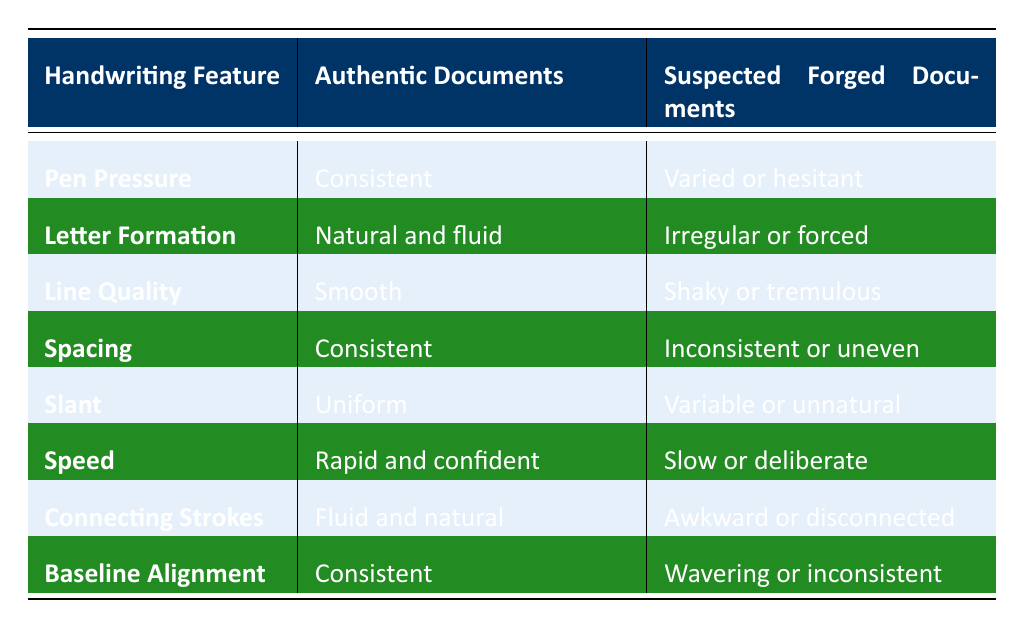What is the description of Pen Pressure in authentic documents? The table states that the Pen Pressure for authentic documents is described as "Consistent". This is directly retrieved from the column under Authentic Documents for the Handwriting Feature of Pen Pressure.
Answer: Consistent How does the Line Quality of suspected forged documents compare to that of authentic documents? The table shows that the Line Quality for authentic documents is "Smooth" while for suspected forged documents it is "Shaky or tremulous". This information is compared directly from the respective rows of the table.
Answer: Shaky or tremulous Is the Spacing of authentic documents described as inconsistent? No, the table indicates that the Spacing for authentic documents is "Consistent". Therefore, the assertion that Spacing is inconsistent is false.
Answer: No What is the difference in Speed between authentic and suspected forged documents? The Speed for authentic documents is "Rapid and confident" while it is "Slow or deliberate" for suspected forged documents. This presents a clear difference from the descriptions given in the table.
Answer: Rapid and confident vs. Slow or deliberate How many handwriting features describe suspected forged documents as having "awkward or disconnected" characteristics? Referring to the table, only the Connecting Strokes feature has the description "Awkward or disconnected" under the Suspected Forged Documents column. It indicates that this unique feature aligns with that specific characteristic upon examination of the data.
Answer: 1 What handwriting features have a description of "Consistent" for authentic documents? From the table, the handwriting features with "Consistent" descriptions for authentic documents are Pen Pressure, Spacing, and Baseline Alignment. These descriptions can be summarized by locating the specified terms in the respective column for authentic documents.
Answer: Pen Pressure, Spacing, Baseline Alignment Are there more handwriting features described as "Natural" in authentic documents than those described as "Irregular" in suspected forged documents? Yes, in the table the features for authentic documents are "Natural and fluid" for Letter Formation and "Fluid and natural" for Connecting Strokes, totaling two features. Meanwhile, the suspected forged documents feature "Irregular or forced" for Letter Formation, which means the count is one. Thus, there are more natural features in authentic documents.
Answer: Yes Which handwriting feature exhibits the greatest contrast between the authentic and suspected forged documents in terms of description? To determine contrast, we compare the descriptions. The greatest difference appears to be in Speed; authentic documents are described as "Rapid and confident", while suspected forgeries are noted to be "Slow or deliberate", which shows a stark contrast in timing.
Answer: Speed 